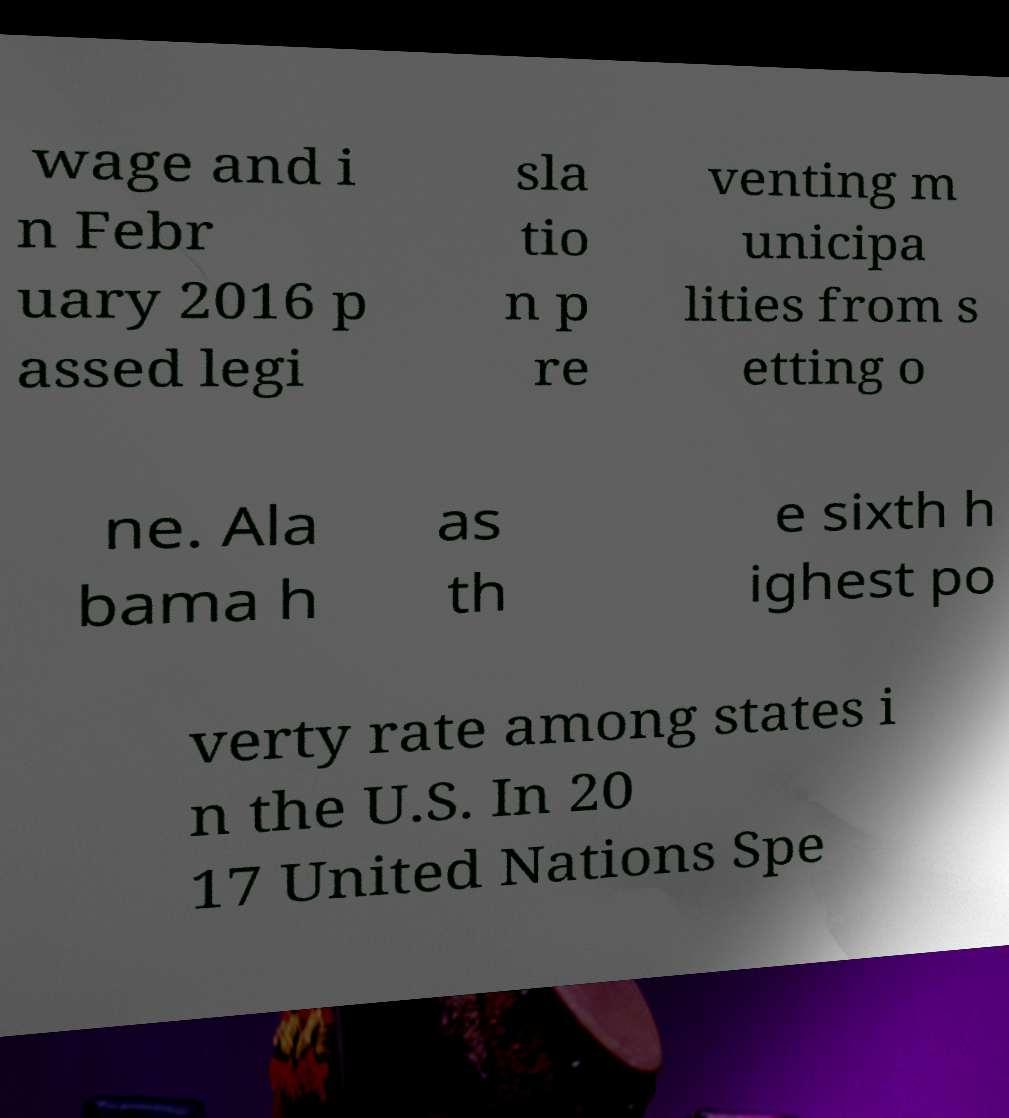For documentation purposes, I need the text within this image transcribed. Could you provide that? wage and i n Febr uary 2016 p assed legi sla tio n p re venting m unicipa lities from s etting o ne. Ala bama h as th e sixth h ighest po verty rate among states i n the U.S. In 20 17 United Nations Spe 